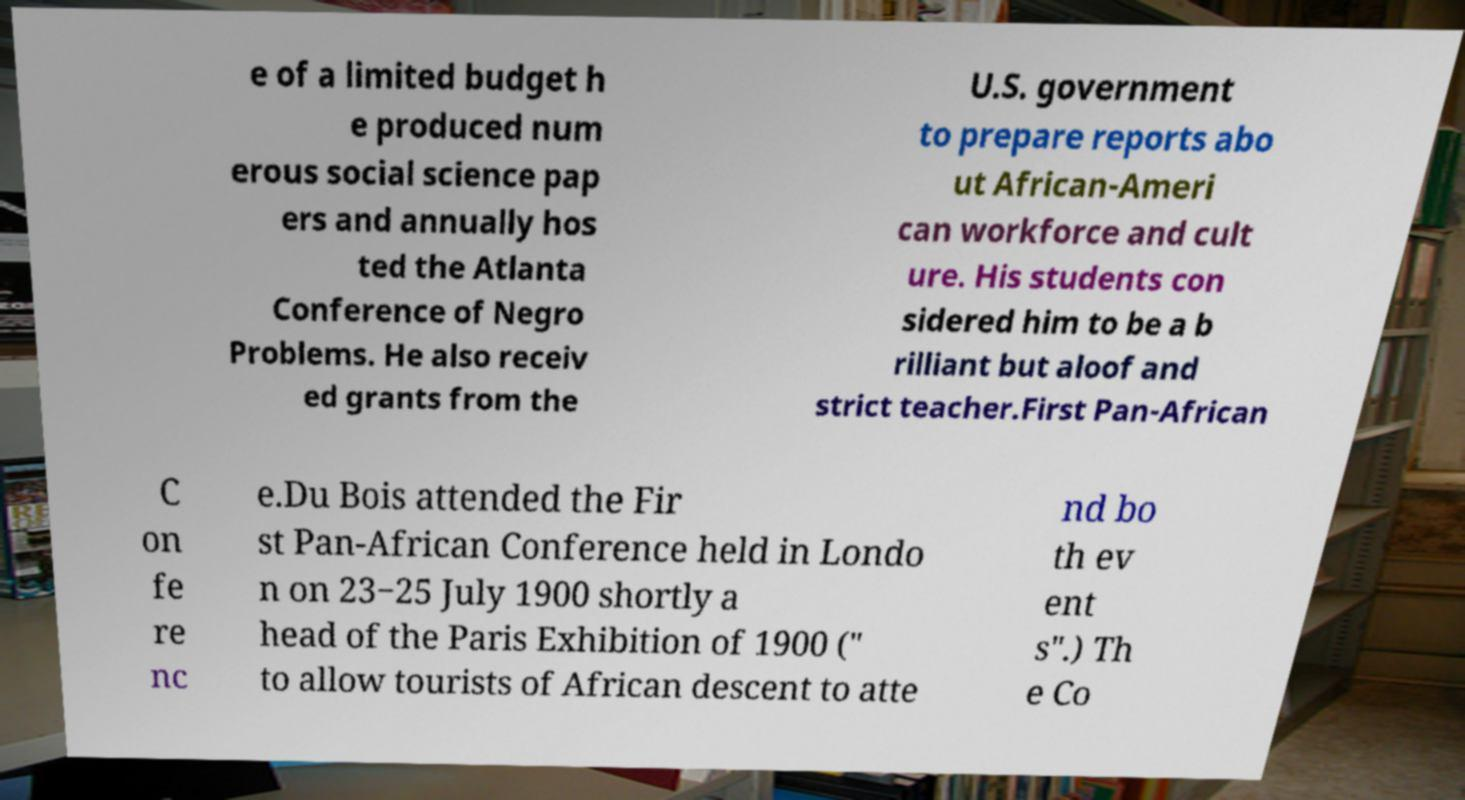Could you extract and type out the text from this image? e of a limited budget h e produced num erous social science pap ers and annually hos ted the Atlanta Conference of Negro Problems. He also receiv ed grants from the U.S. government to prepare reports abo ut African-Ameri can workforce and cult ure. His students con sidered him to be a b rilliant but aloof and strict teacher.First Pan-African C on fe re nc e.Du Bois attended the Fir st Pan-African Conference held in Londo n on 23−25 July 1900 shortly a head of the Paris Exhibition of 1900 (" to allow tourists of African descent to atte nd bo th ev ent s".) Th e Co 